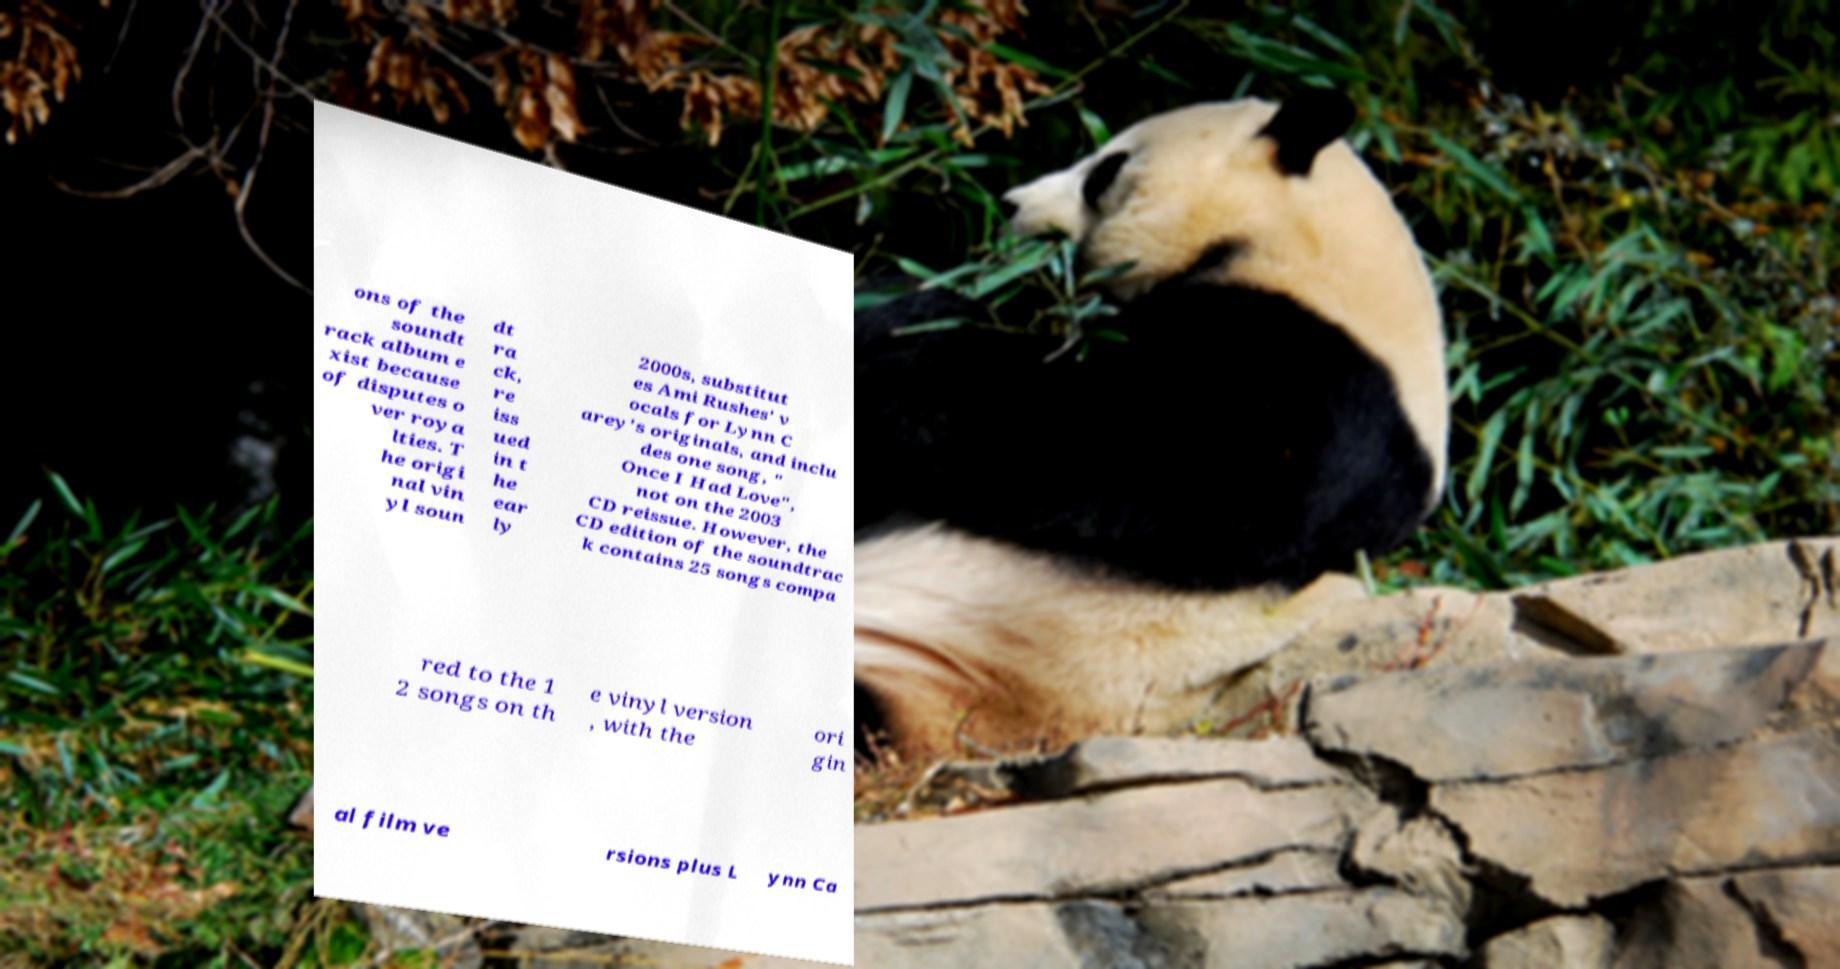Could you assist in decoding the text presented in this image and type it out clearly? ons of the soundt rack album e xist because of disputes o ver roya lties. T he origi nal vin yl soun dt ra ck, re iss ued in t he ear ly 2000s, substitut es Ami Rushes' v ocals for Lynn C arey's originals, and inclu des one song, " Once I Had Love", not on the 2003 CD reissue. However, the CD edition of the soundtrac k contains 25 songs compa red to the 1 2 songs on th e vinyl version , with the ori gin al film ve rsions plus L ynn Ca 